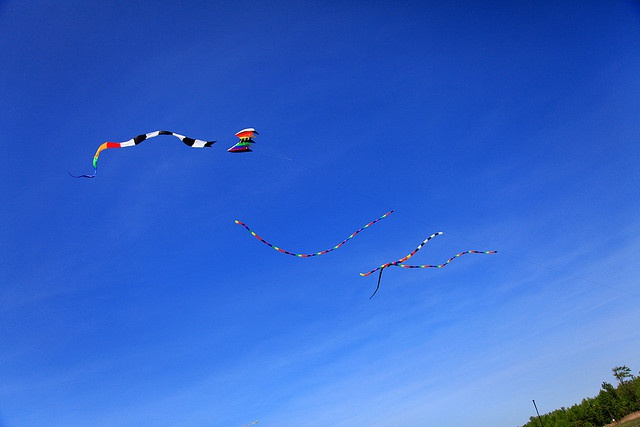Describe the objects in this image and their specific colors. I can see kite in darkblue, black, blue, white, and red tones, kite in darkblue, blue, red, and yellow tones, kite in darkblue, blue, red, black, and ivory tones, and kite in darkblue, navy, red, lightblue, and gray tones in this image. 